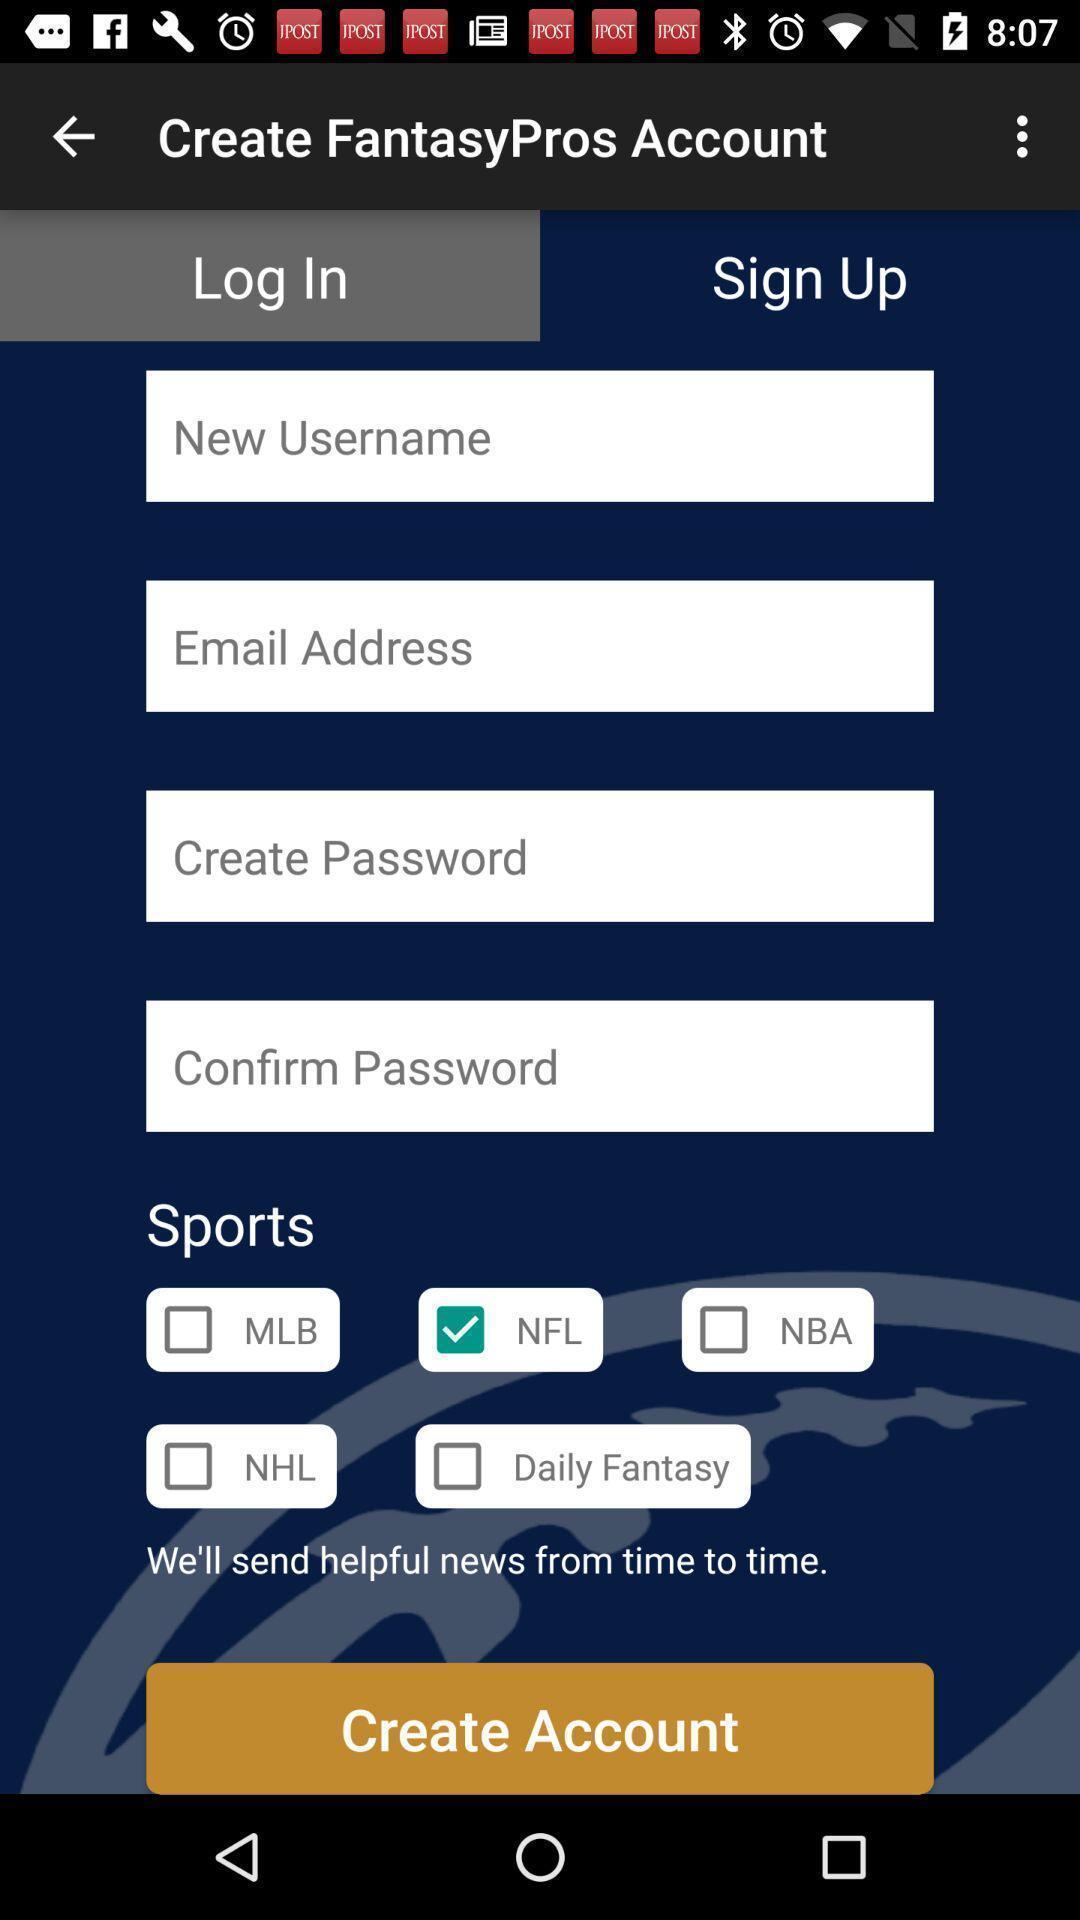Please provide a description for this image. Starting page to create the account in sports application. 